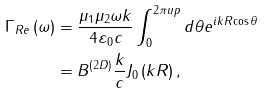Convert formula to latex. <formula><loc_0><loc_0><loc_500><loc_500>\Gamma _ { R e } \left ( \omega \right ) & = \frac { \mu _ { 1 } \mu _ { 2 } \omega k } { 4 { \varepsilon } _ { 0 } c } \int ^ { 2 \pi u p } _ { 0 } { d \theta e ^ { i k R { \cos \theta } } } \\ & = B ^ { \left ( 2 D \right ) } \frac { k } { c } J _ { 0 } \left ( k R \right ) ,</formula> 